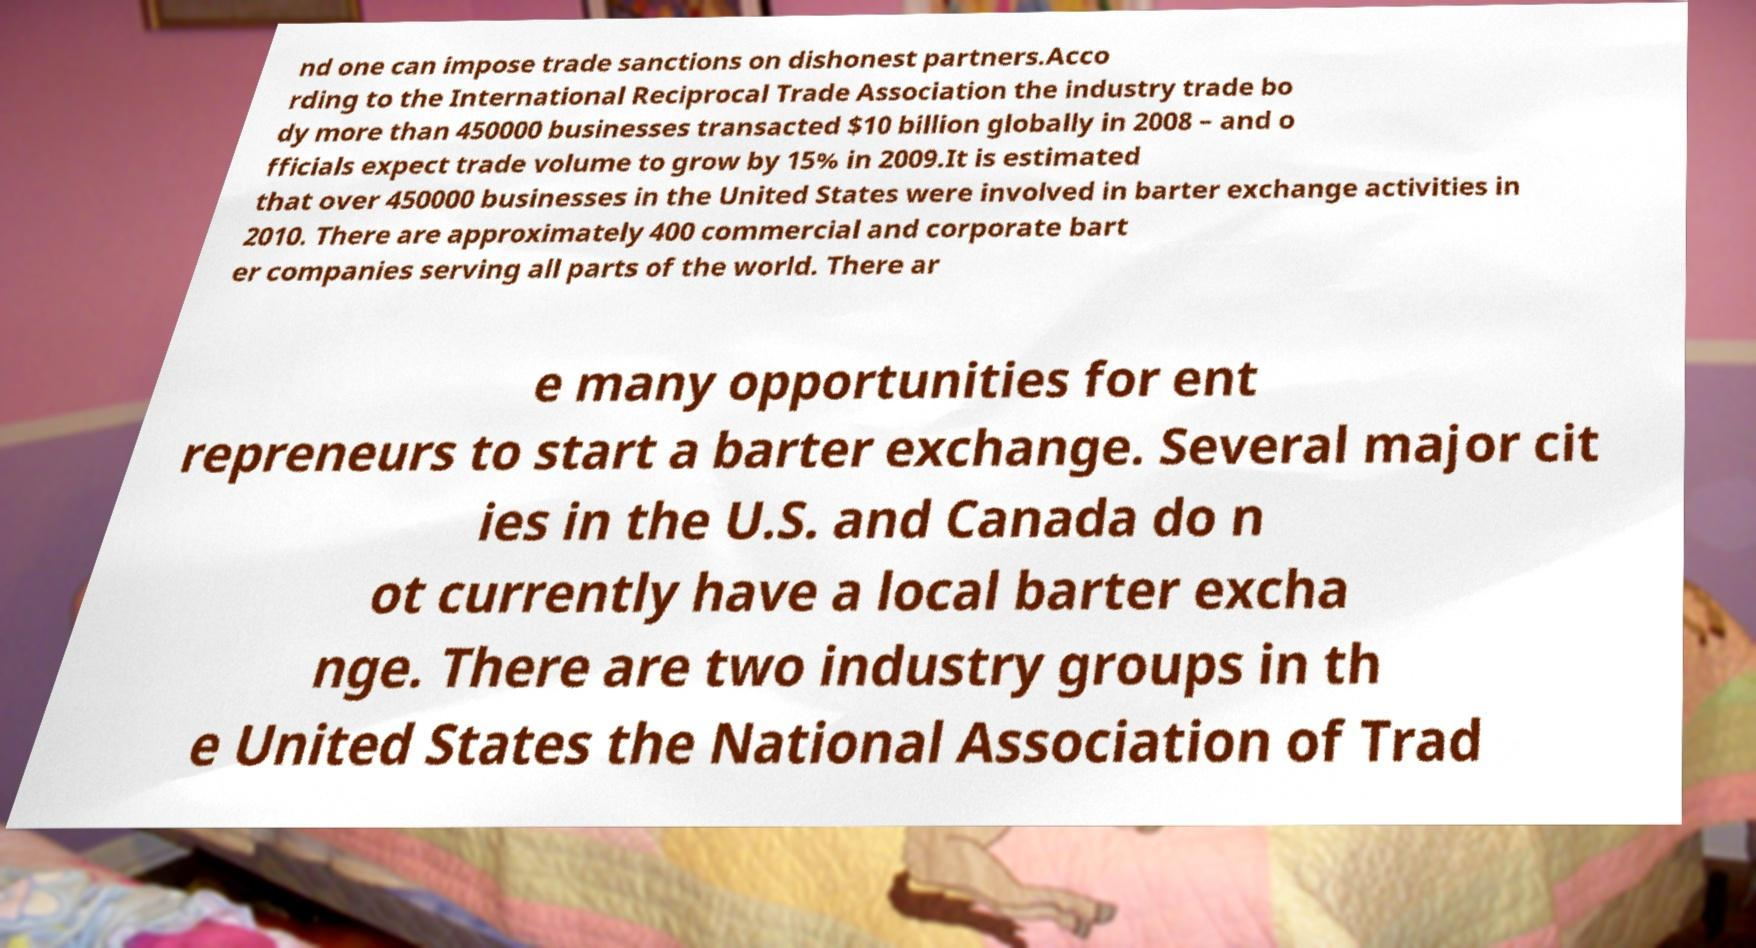Can you read and provide the text displayed in the image?This photo seems to have some interesting text. Can you extract and type it out for me? nd one can impose trade sanctions on dishonest partners.Acco rding to the International Reciprocal Trade Association the industry trade bo dy more than 450000 businesses transacted $10 billion globally in 2008 – and o fficials expect trade volume to grow by 15% in 2009.It is estimated that over 450000 businesses in the United States were involved in barter exchange activities in 2010. There are approximately 400 commercial and corporate bart er companies serving all parts of the world. There ar e many opportunities for ent repreneurs to start a barter exchange. Several major cit ies in the U.S. and Canada do n ot currently have a local barter excha nge. There are two industry groups in th e United States the National Association of Trad 